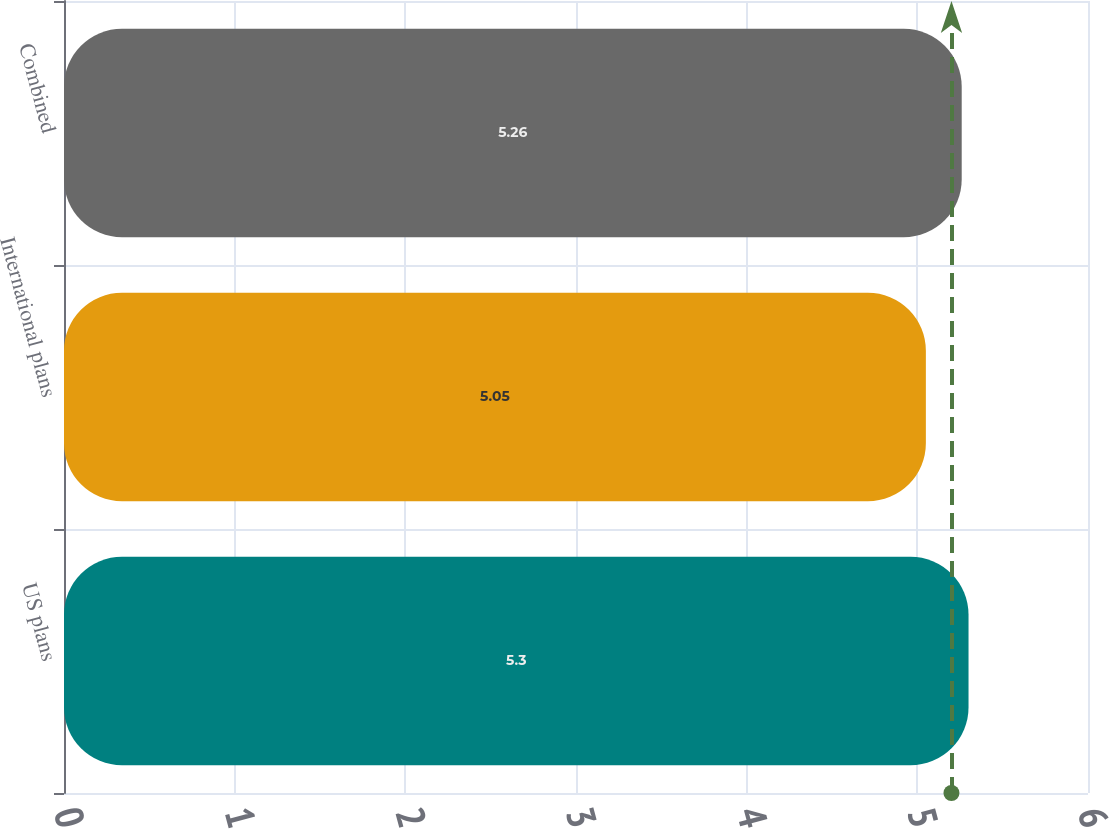<chart> <loc_0><loc_0><loc_500><loc_500><bar_chart><fcel>US plans<fcel>International plans<fcel>Combined<nl><fcel>5.3<fcel>5.05<fcel>5.26<nl></chart> 